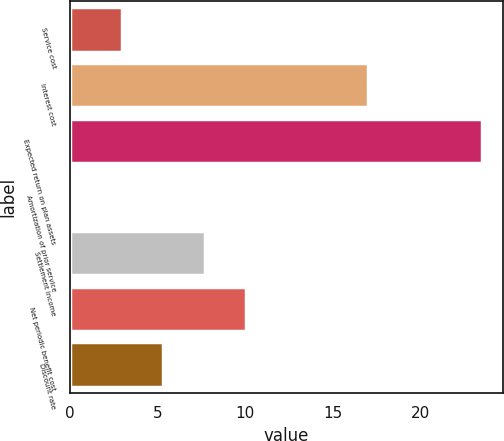Convert chart to OTSL. <chart><loc_0><loc_0><loc_500><loc_500><bar_chart><fcel>Service cost<fcel>Interest cost<fcel>Expected return on plan assets<fcel>Amortization of prior service<fcel>Settlement income<fcel>Net periodic benefit cost<fcel>Discount rate<nl><fcel>3<fcel>17<fcel>23.5<fcel>0.1<fcel>7.68<fcel>10.02<fcel>5.34<nl></chart> 